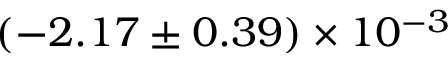<formula> <loc_0><loc_0><loc_500><loc_500>( - 2 . 1 7 \pm 0 . 3 9 ) \times 1 0 ^ { - 3 }</formula> 